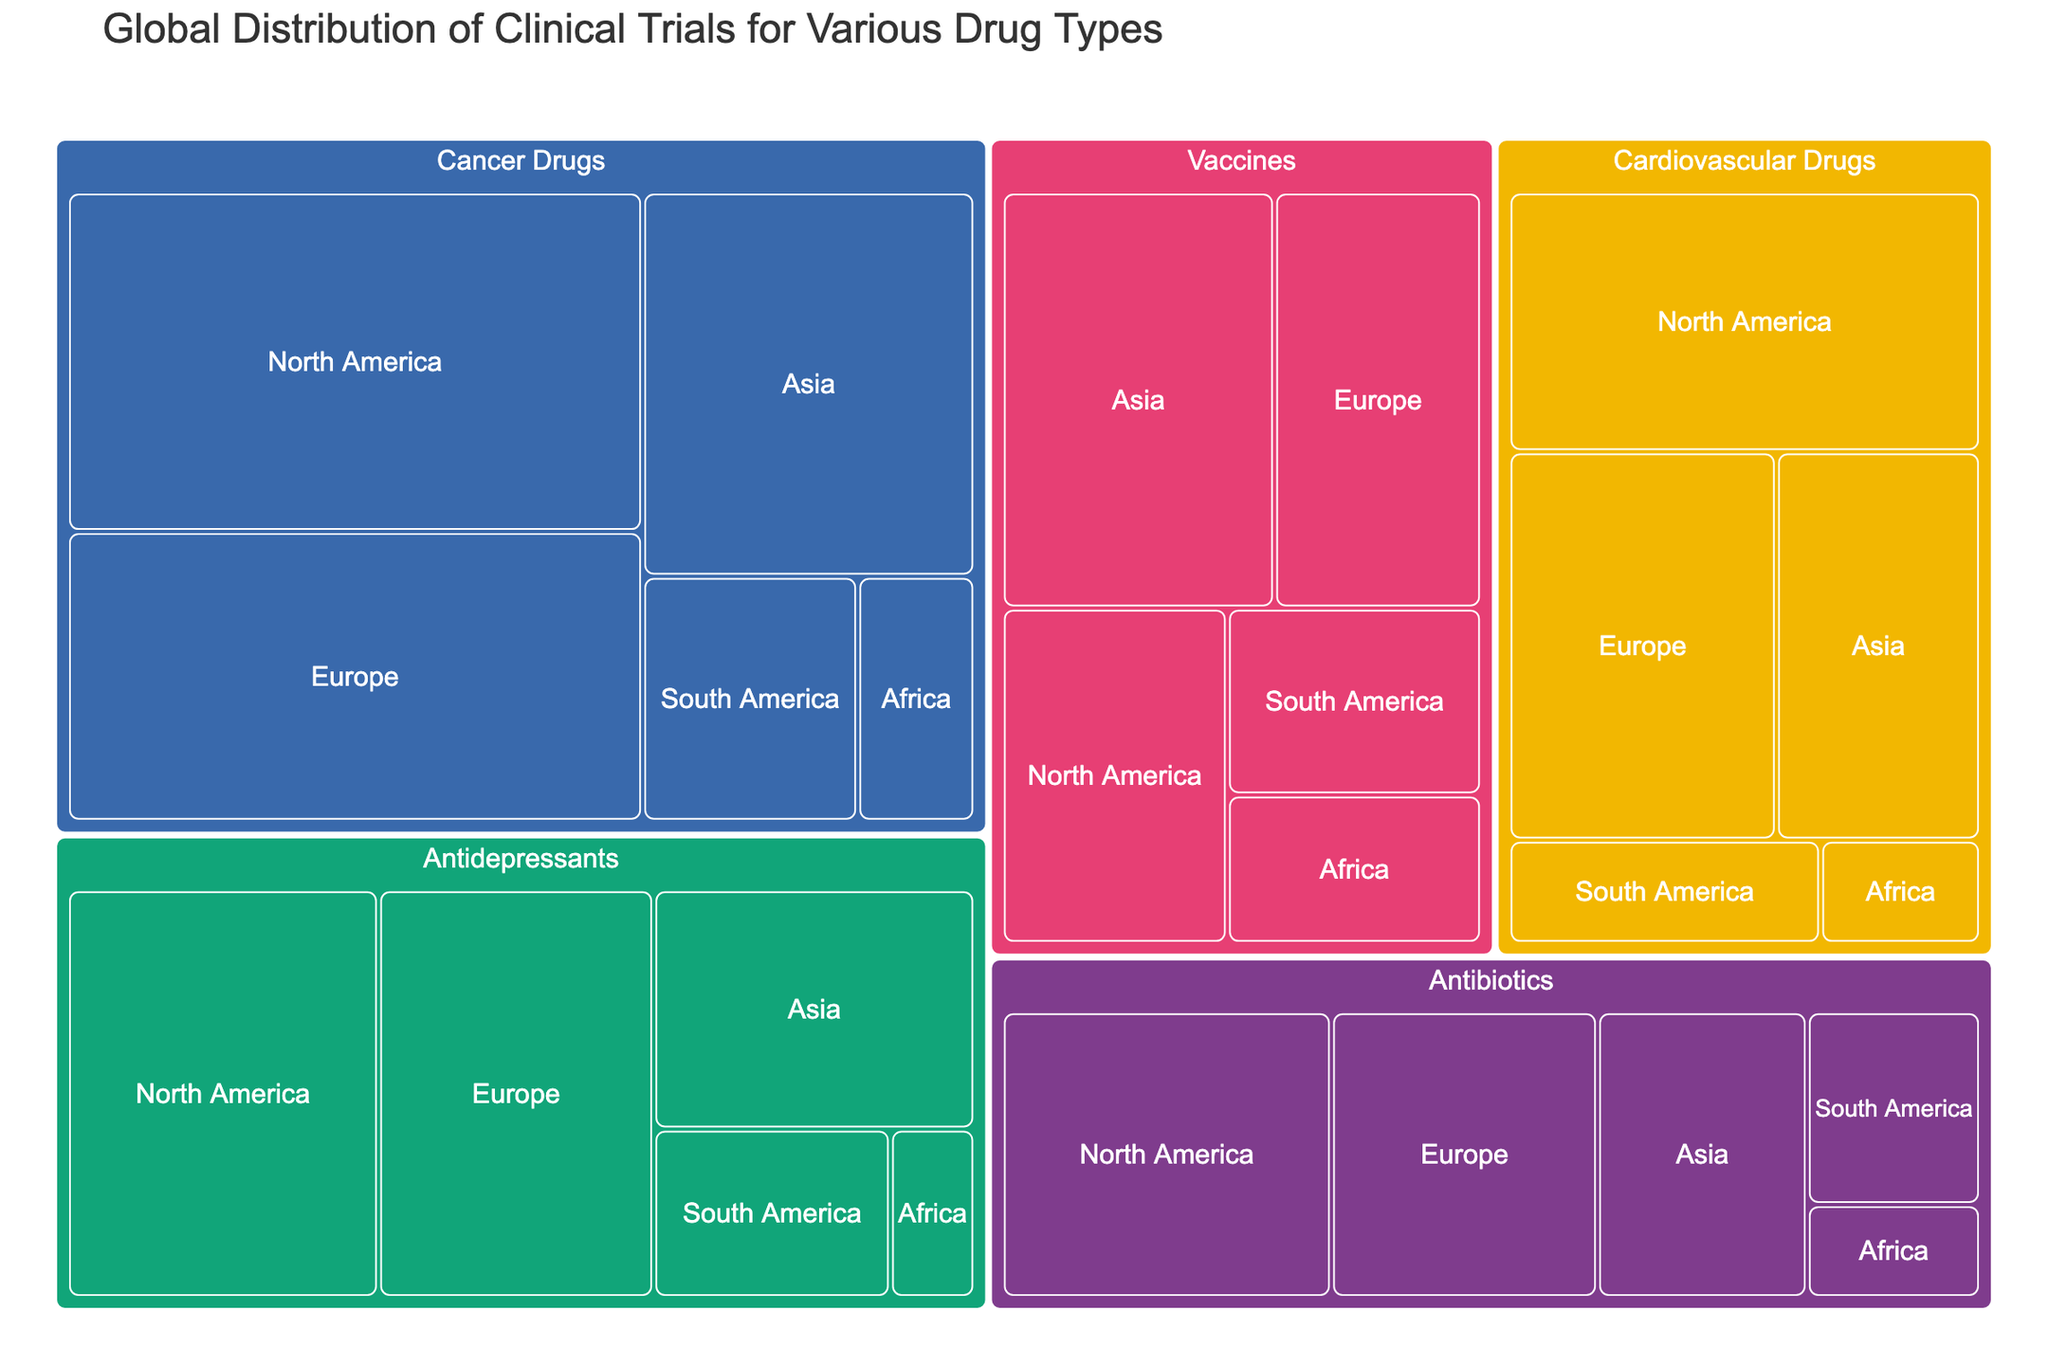What is the title of the treemap? The title of the treemap can be found at the top of the figure.
Answer: "Global Distribution of Clinical Trials for Various Drug Types" Which region has the highest number of clinical trials for Cancer Drugs? Locate the Cancer Drugs category and then identify the region with the largest block within this category.
Answer: North America How many clinical trials are there for Vaccines in Europe and Asia combined? Find the number of clinical trials for Vaccines in Europe and Asia and sum them up: 203 + 267.
Answer: 470 Which Drug Type has the smallest presence in Africa? Look for the region Africa and compare the sizes of the blocks for different Drug Types within this region.
Answer: Antidepressants What’s the difference in the number of clinical trials between Cardiovascular Drugs in North America and South America? Find the number of clinical trials for Cardiovascular Drugs in North America and South America and subtract one from the other: 289 - 76.
Answer: 213 Which region has the lowest number of Antibiotics clinical trials? Locate the Antibiotics category and identify the region with the smallest block.
Answer: Africa Compare the number of clinical trials for Antidepressants in North America and Europe. Which has more? Look at the number of clinical trials for Antidepressants in North America (312) and in Europe (276) and determine which value is higher.
Answer: North America How many more clinical trials are there for Cancer Drugs in Europe compared to Antibiotics in Asia? Subtract the number of clinical trials for Antibiotics in Asia from Cancer Drugs in Europe: 389 - 156.
Answer: 233 Which Drug Type has the largest total number of clinical trials across all regions? Sum the number of clinical trials for each Drug Type across all regions and compare the totals. Cancer Drugs have (456 + 389 + 298 + 123 + 67) = 1333; other Drug Types have fewer total trials.
Answer: Cancer Drugs What is the average number of clinical trials for Vaccines across all regions? Sum the number of clinical trials for Vaccines across all regions and divide by the number of regions (5): (178 + 203 + 267 + 112 + 89) / 5.
Answer: 169.8 